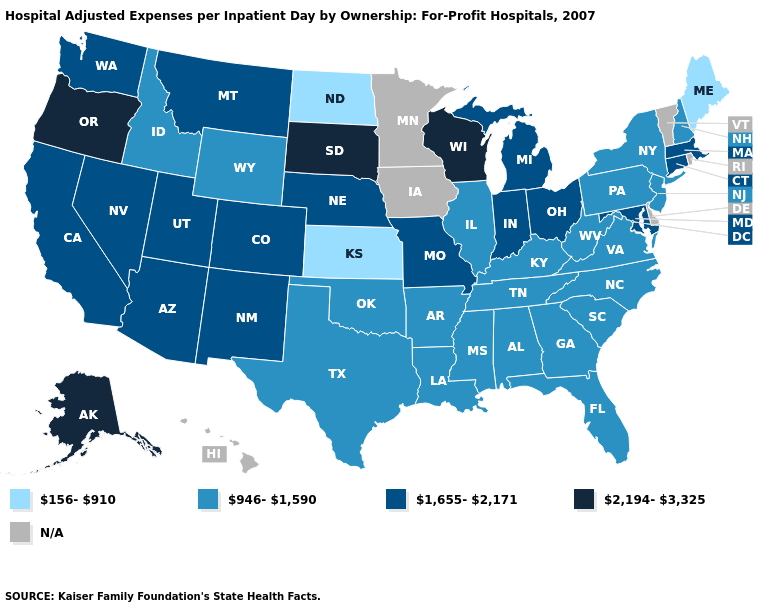What is the value of Rhode Island?
Concise answer only. N/A. What is the value of West Virginia?
Quick response, please. 946-1,590. Which states hav the highest value in the West?
Be succinct. Alaska, Oregon. What is the value of Idaho?
Answer briefly. 946-1,590. Does Maine have the lowest value in the USA?
Quick response, please. Yes. Among the states that border Indiana , does Ohio have the lowest value?
Keep it brief. No. What is the value of Vermont?
Short answer required. N/A. What is the value of Oregon?
Concise answer only. 2,194-3,325. What is the highest value in states that border Wisconsin?
Answer briefly. 1,655-2,171. What is the value of Montana?
Quick response, please. 1,655-2,171. Name the states that have a value in the range N/A?
Be succinct. Delaware, Hawaii, Iowa, Minnesota, Rhode Island, Vermont. What is the highest value in the MidWest ?
Be succinct. 2,194-3,325. What is the value of New York?
Short answer required. 946-1,590. What is the value of Kansas?
Quick response, please. 156-910. What is the value of Maine?
Keep it brief. 156-910. 